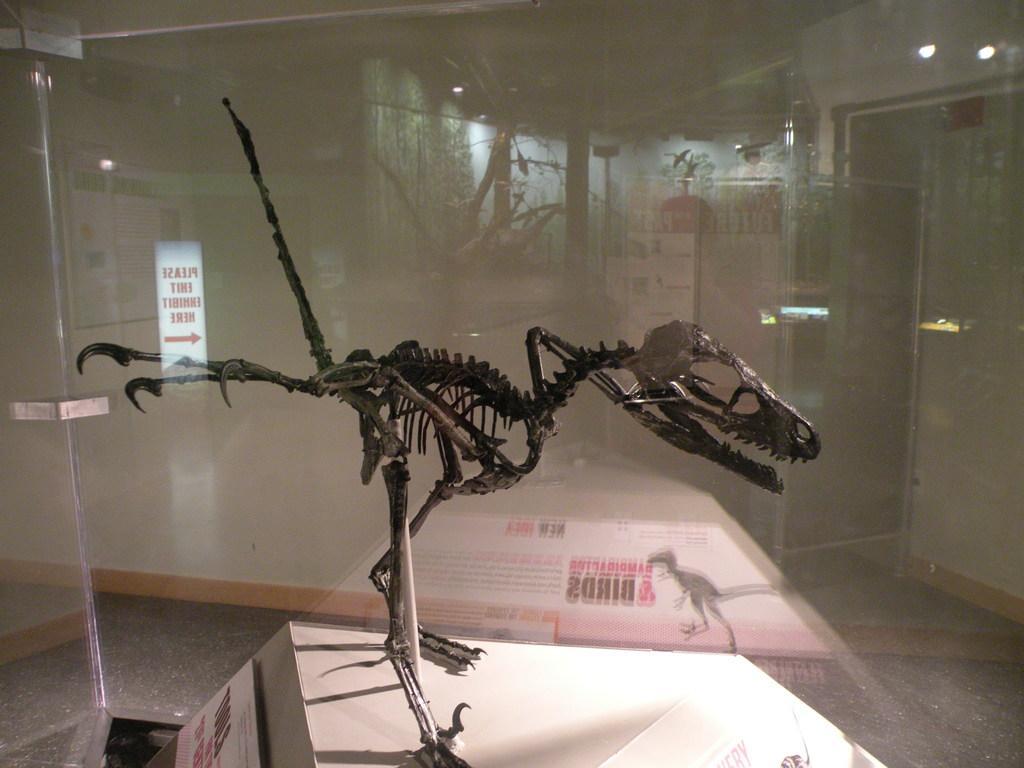Could you give a brief overview of what you see in this image? In this picture there is a dinosaur skeleton in the center of the image, inside a glass box. 